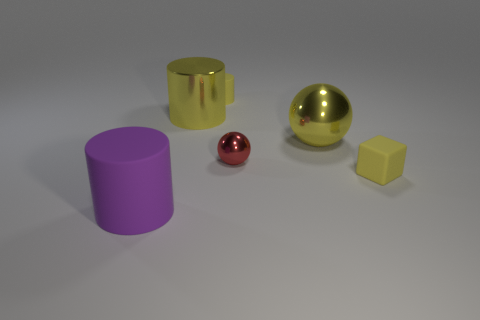Subtract all tiny cylinders. How many cylinders are left? 2 Subtract all yellow spheres. How many spheres are left? 1 Subtract 2 spheres. How many spheres are left? 0 Subtract all brown things. Subtract all yellow rubber cubes. How many objects are left? 5 Add 3 cylinders. How many cylinders are left? 6 Add 2 small red objects. How many small red objects exist? 3 Add 4 metallic cylinders. How many objects exist? 10 Subtract 0 gray cylinders. How many objects are left? 6 Subtract all blocks. How many objects are left? 5 Subtract all brown cylinders. Subtract all brown balls. How many cylinders are left? 3 